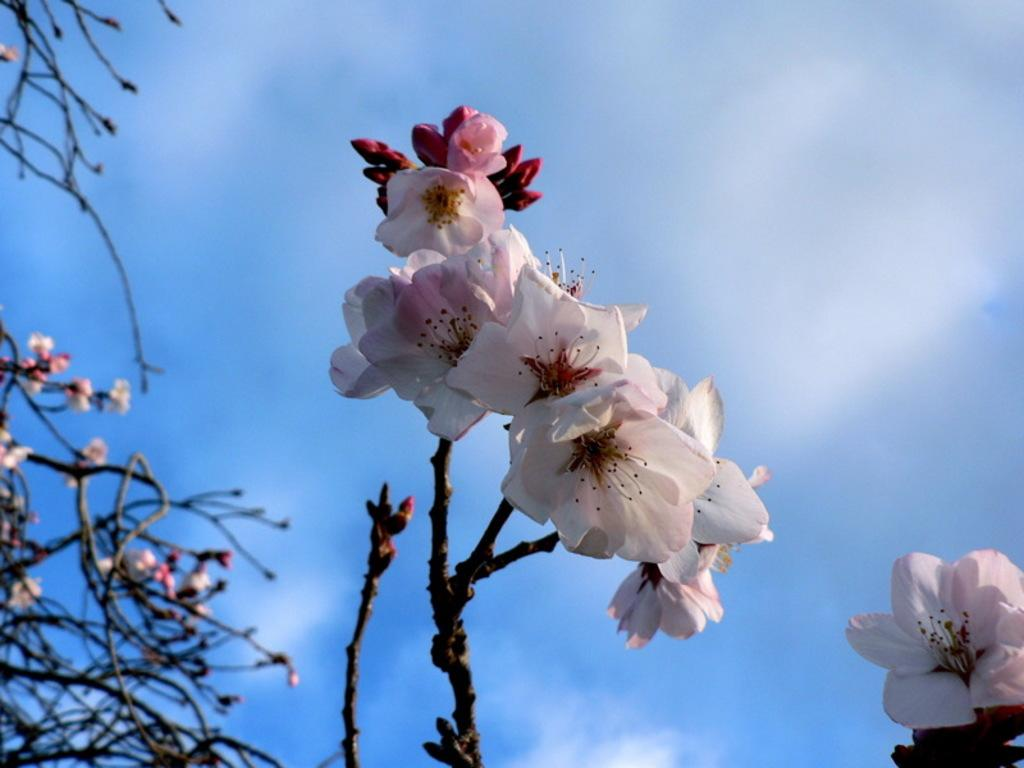What type of flora is present in the image? There are flowers in the image. What colors can be seen in the flowers? The flowers are in white and pink colors. What can be seen in the background of the image? The sky is visible in the background of the image. What colors are present in the sky? The sky is in white and blue colors. Can you tell me what the woman is thinking about while looking at the flowers in the image? There is no woman present in the image, so it is not possible to determine her thoughts. 